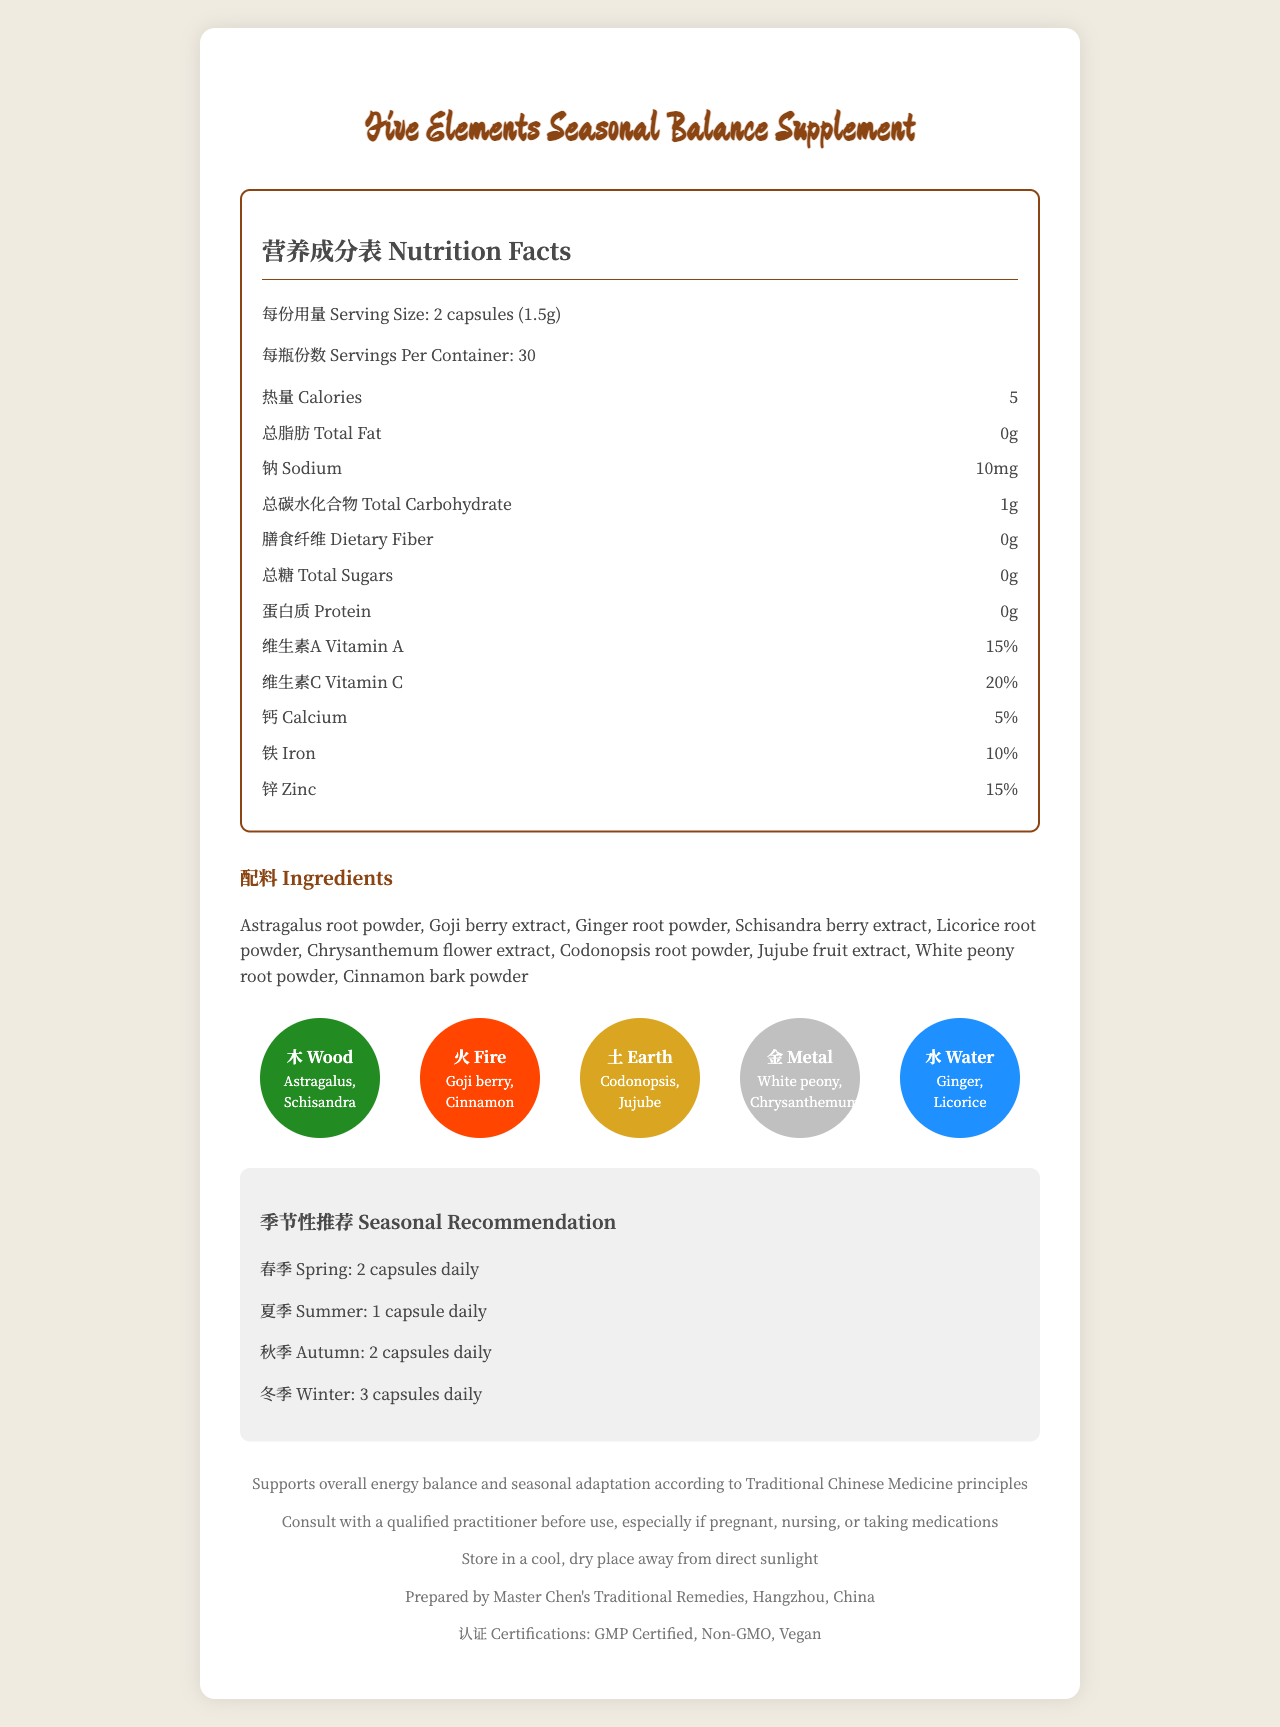What is the serving size for the Five Elements Seasonal Balance Supplement? The document specifies the serving size as "2 capsules (1.5g)".
Answer: 2 capsules (1.5g) How many servings are there per container? The document states that there are 30 servings per container.
Answer: 30 Which vitamins are present in the supplement, and what are their percentages? The nutrition facts section lists Vitamin A with a 15% daily value and Vitamin C with a 20% daily value.
Answer: Vitamin A (15%) and Vitamin C (20%) List three ingredients of the supplement. The ingredients listed in the document include Astragalus root powder, Goji berry extract, and Ginger root powder.
Answer: Astragalus root powder, Goji berry extract, Ginger root powder What is the recommended daily dosage for winter? The seasonal recommendation section advises taking 3 capsules daily in winter.
Answer: 3 capsules daily In which category do Astragalus and Schisandra fall under the Five Elements theory? The elemental properties section places Astragalus and Schisandra under the Wood category.
Answer: Wood What is the storage instruction for this supplement? The storage instructions section advises keeping the supplement in a cool, dry place away from direct sunlight.
Answer: Store in a cool, dry place away from direct sunlight What is the percentage of calcium in the supplement? The nutrition facts section indicates that calcium makes up 5% of the daily value.
Answer: 5% How many calories are there per serving? The nutrition facts section shows that there are 5 calories per serving.
Answer: 5 What is the main purpose of this supplement according to Traditional Chinese Medicine principles? The traditional usage statement explains that the supplement supports overall energy balance and seasonal adaptation according to Traditional Chinese Medicine principles.
Answer: Supports overall energy balance and seasonal adaptation Which certification is not listed for this product? A. Organic B. GMP Certified C. Non-GMO D. Vegan The certifications listed are GMP Certified, Non-GMO, and Vegan; Organic is not mentioned.
Answer: A. Organic Which ingredient is associated with the Water element? A. Goji berry B. Ginger root powder C. Codonopsis root powder D. White peony root powder The elemental properties section associates Water with Ginger root powder and Licorice root powder.
Answer: B. Ginger root powder What percentage of Iron does the supplement provide? The nutrition facts section lists 10% for Iron.
Answer: 10% Is the total sugar content in the supplement greater than 1g per serving? The document indicates that the total sugar content is 0g per serving, which is not greater than 1g.
Answer: No What should you do before using this supplement if you are pregnant or nursing? The cautionary statement advises consulting with a qualified practitioner before use, especially if pregnant or nursing.
Answer: Consult with a qualified practitioner Describe the main idea of the document. This summary captures the key sections and overall purpose of the document.
Answer: The document provides detailed information about the Five Elements Seasonal Balance Supplement, including its serving size, nutritional content, ingredients classified by the Five Elements theory, seasonal dosage recommendations, traditional usage, storage instructions, cautionary statements, and certifications. How can the nutrients in this supplement benefit someone who is lacking dietary fiber? The document does not provide specific information on how the supplement's nutrients would benefit someone lacking dietary fiber, especially since it contains 0g of dietary fiber.
Answer: Not enough information 